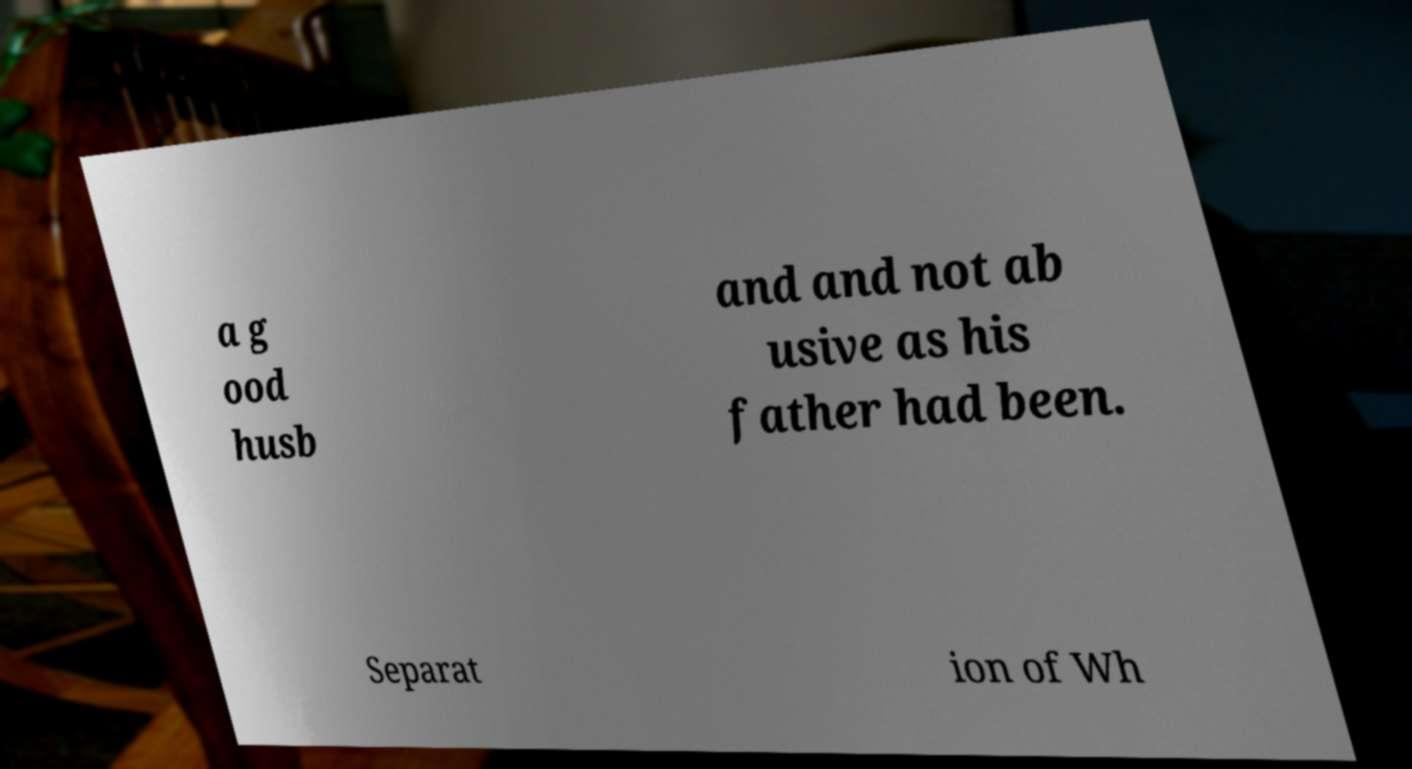I need the written content from this picture converted into text. Can you do that? a g ood husb and and not ab usive as his father had been. Separat ion of Wh 